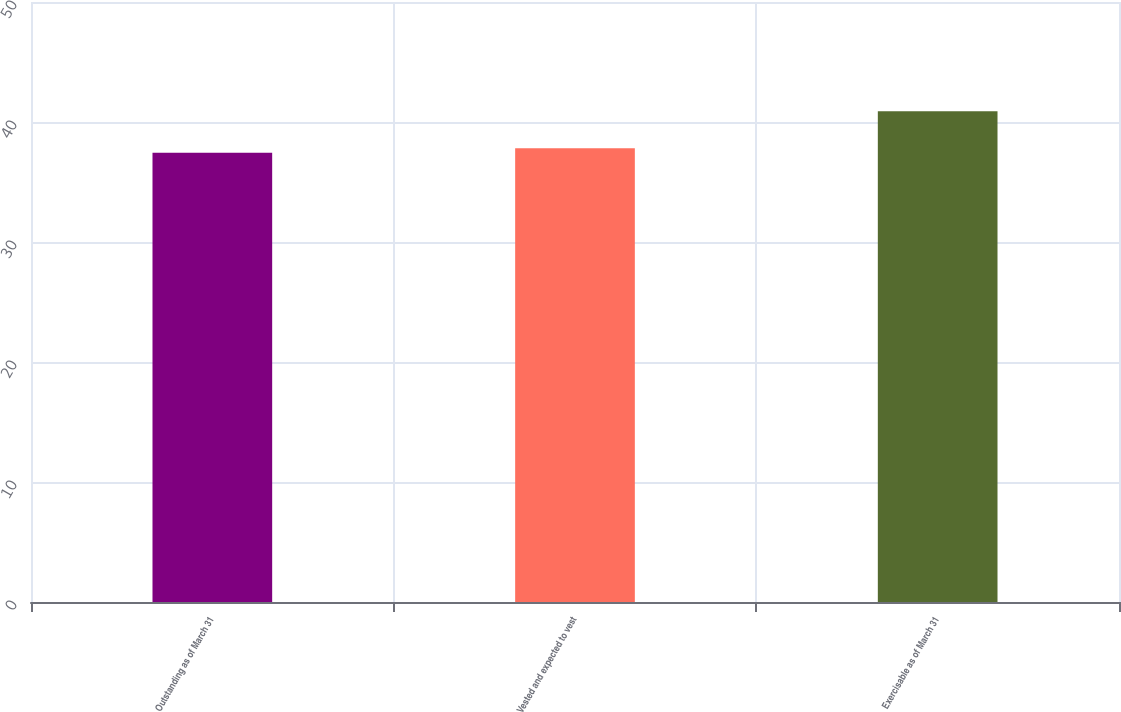<chart> <loc_0><loc_0><loc_500><loc_500><bar_chart><fcel>Outstanding as of March 31<fcel>Vested and expected to vest<fcel>Exercisable as of March 31<nl><fcel>37.44<fcel>37.82<fcel>40.9<nl></chart> 